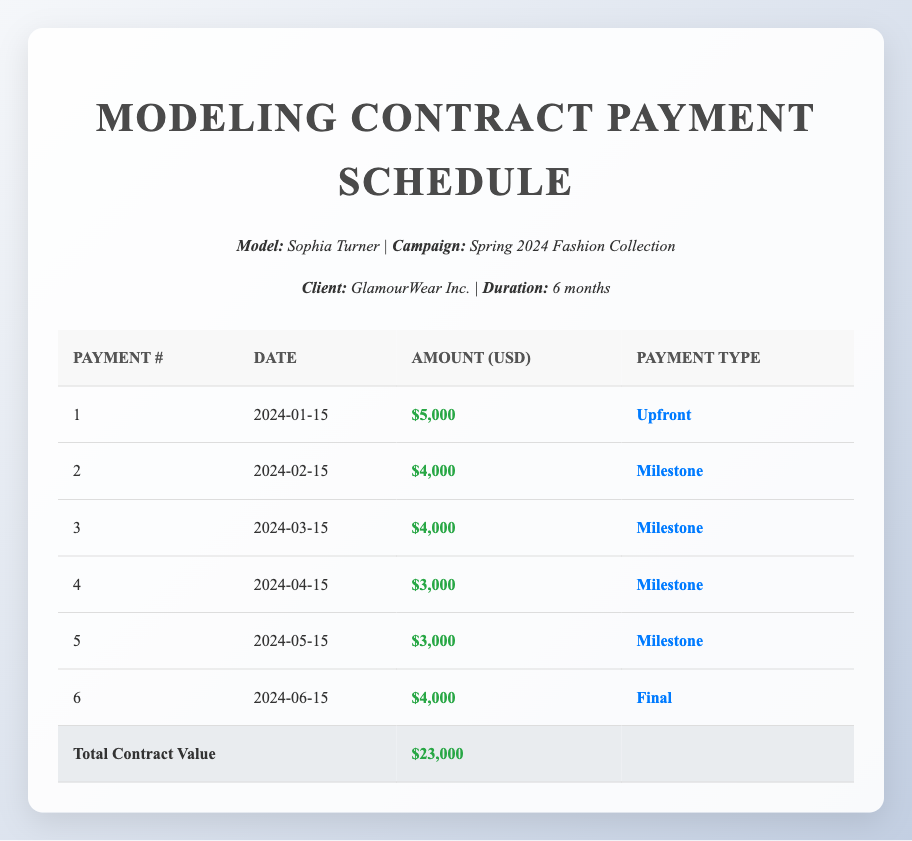What is the total contract value for the modeling contract? The total contract value is mentioned in the last row of the table, where it states "Total Contract Value" followed by "$23,000".
Answer: 23000 How much will be paid upfront for the contract? The upfront payment is the first row of the table, which shows a payment amount of "$5,000" listed under the "Amount" column.
Answer: 5000 What is the total amount paid across all milestone payments? The total must be calculated by summing the amounts in the "Amount" column for payments classified as "Milestone": $4,000 (payment 2) + $4,000 (payment 3) + $3,000 (payment 4) + $3,000 (payment 5) = $14,000.
Answer: 14000 Is the final payment amount greater than the upfront payment? The final payment is $4,000 (payment 6), while the upfront payment is $5,000 (payment 1). Since $4,000 is less than $5,000, the answer is no.
Answer: No What is the average payment amount across all six payments? To find the average, sum all payment amounts ($5,000 + $4,000 + $4,000 + $3,000 + $3,000 + $4,000 = $23,000) and divide by the number of payments (6); thus, $23,000 / 6 = $3,833.33.
Answer: 3833.33 What was the payment structure for the second month of the contract? The second month corresponds to payment number 2, which is on "2024-02-15" for an amount of "$4,000" with "Milestone" as the payment type.
Answer: Payment date: 2024-02-15, Amount: 4000, Type: Milestone How many payments are classified as milestones? By reviewing the "Payment Type" column, there are four payments listed as "Milestone": payments 2, 3, 4, and 5.
Answer: 4 Was the last payment made in the same month as the contract's end? The last payment is listed on "2024-06-15," which is exactly the last month (June) of the contract that lasts 6 months (starting in January). Thus, the answer is yes.
Answer: Yes What is the difference in payment amounts between the largest and smallest payment? The largest payment is $5,000 (upfront) and the smallest payment is $3,000 (milestones 4 and 5). The difference is calculated as $5,000 - $3,000 = $2,000.
Answer: 2000 